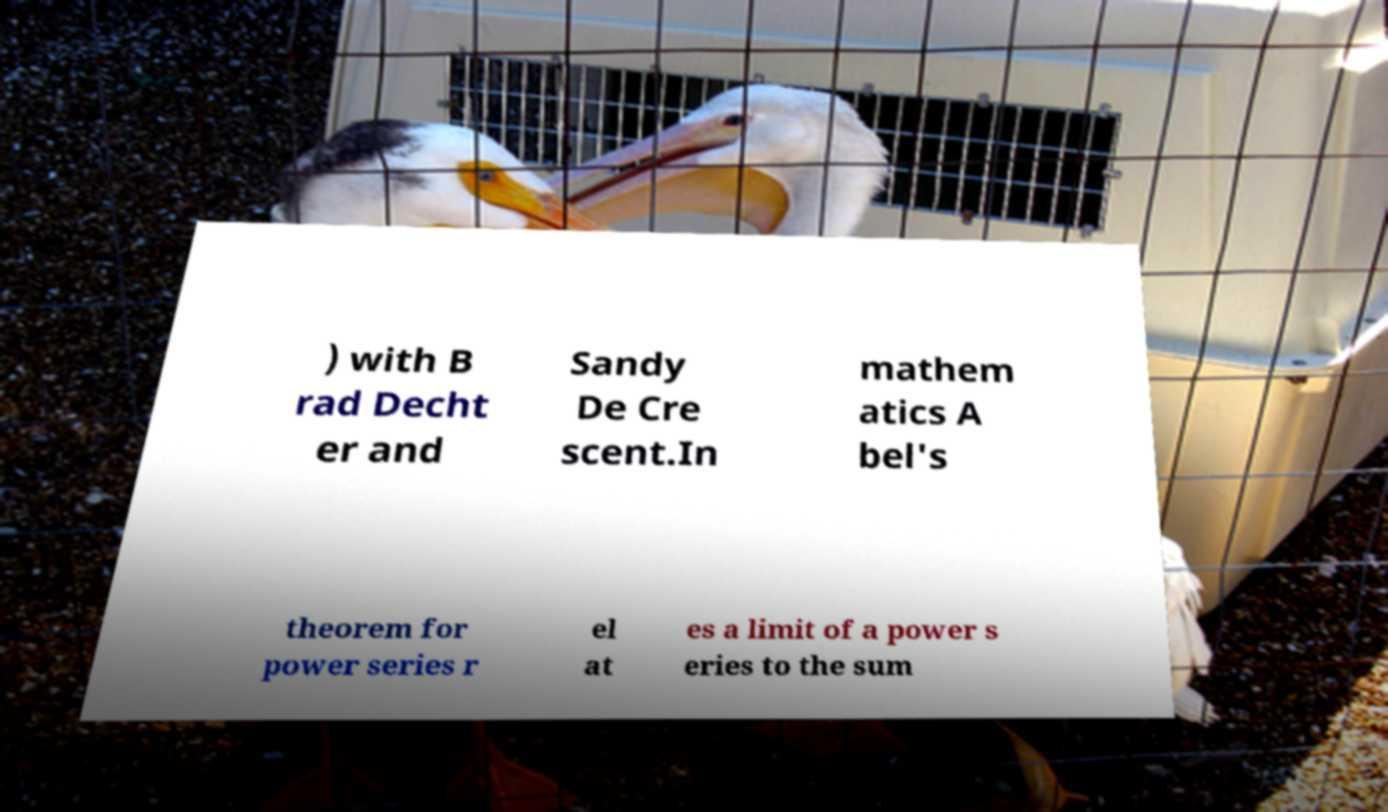For documentation purposes, I need the text within this image transcribed. Could you provide that? ) with B rad Decht er and Sandy De Cre scent.In mathem atics A bel's theorem for power series r el at es a limit of a power s eries to the sum 